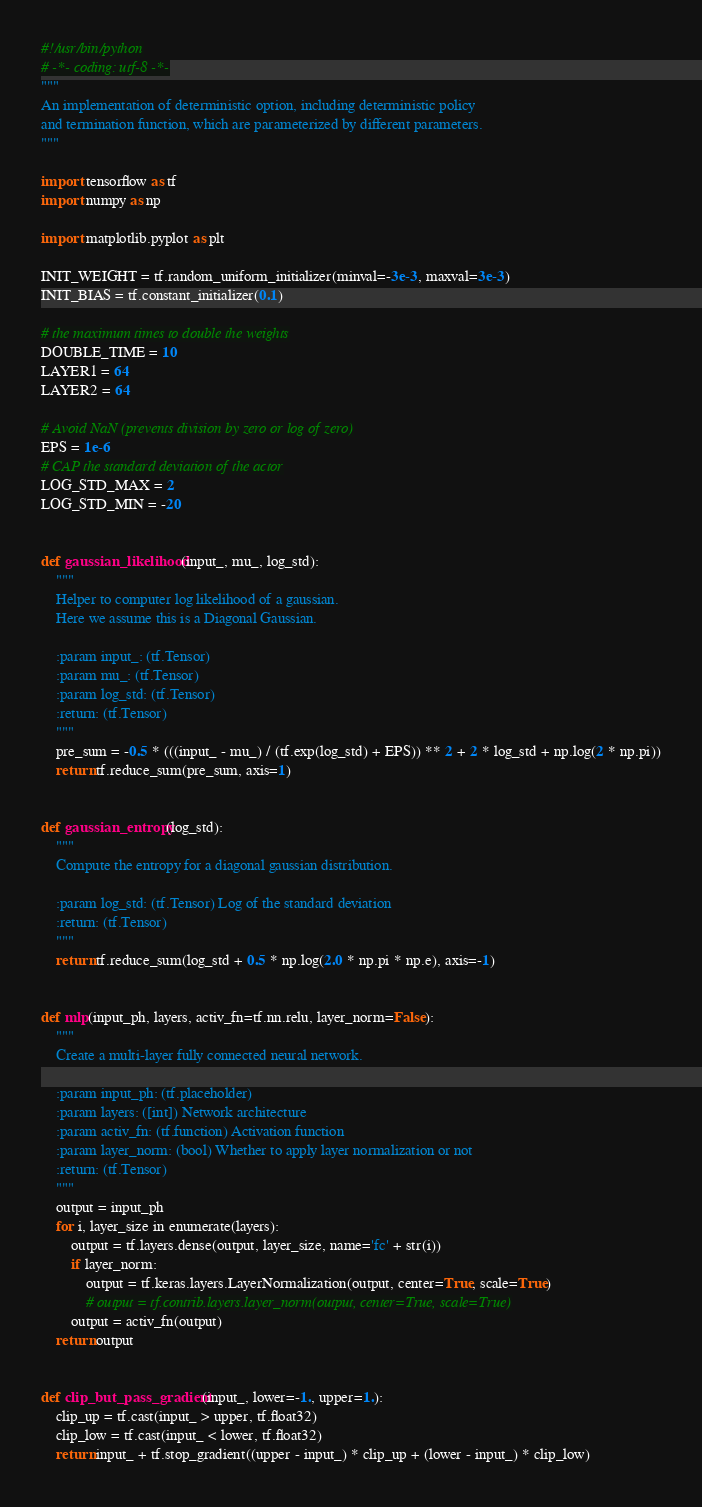<code> <loc_0><loc_0><loc_500><loc_500><_Python_>#!/usr/bin/python
# -*- coding: utf-8 -*-
"""
An implementation of deterministic option, including deterministic policy
and termination function, which are parameterized by different parameters.
"""

import tensorflow as tf
import numpy as np

import matplotlib.pyplot as plt

INIT_WEIGHT = tf.random_uniform_initializer(minval=-3e-3, maxval=3e-3)
INIT_BIAS = tf.constant_initializer(0.1)

# the maximum times to double the weights
DOUBLE_TIME = 10
LAYER1 = 64
LAYER2 = 64

# Avoid NaN (prevents division by zero or log of zero)
EPS = 1e-6
# CAP the standard deviation of the actor
LOG_STD_MAX = 2
LOG_STD_MIN = -20


def gaussian_likelihood(input_, mu_, log_std):
    """
    Helper to computer log likelihood of a gaussian.
    Here we assume this is a Diagonal Gaussian.

    :param input_: (tf.Tensor)
    :param mu_: (tf.Tensor)
    :param log_std: (tf.Tensor)
    :return: (tf.Tensor)
    """
    pre_sum = -0.5 * (((input_ - mu_) / (tf.exp(log_std) + EPS)) ** 2 + 2 * log_std + np.log(2 * np.pi))
    return tf.reduce_sum(pre_sum, axis=1)


def gaussian_entropy(log_std):
    """
    Compute the entropy for a diagonal gaussian distribution.

    :param log_std: (tf.Tensor) Log of the standard deviation
    :return: (tf.Tensor)
    """
    return tf.reduce_sum(log_std + 0.5 * np.log(2.0 * np.pi * np.e), axis=-1)


def mlp(input_ph, layers, activ_fn=tf.nn.relu, layer_norm=False):
    """
    Create a multi-layer fully connected neural network.

    :param input_ph: (tf.placeholder)
    :param layers: ([int]) Network architecture
    :param activ_fn: (tf.function) Activation function
    :param layer_norm: (bool) Whether to apply layer normalization or not
    :return: (tf.Tensor)
    """
    output = input_ph
    for i, layer_size in enumerate(layers):
        output = tf.layers.dense(output, layer_size, name='fc' + str(i))
        if layer_norm:
            output = tf.keras.layers.LayerNormalization(output, center=True, scale=True)
            # output = tf.contrib.layers.layer_norm(output, center=True, scale=True)
        output = activ_fn(output)
    return output


def clip_but_pass_gradient(input_, lower=-1., upper=1.):
    clip_up = tf.cast(input_ > upper, tf.float32)
    clip_low = tf.cast(input_ < lower, tf.float32)
    return input_ + tf.stop_gradient((upper - input_) * clip_up + (lower - input_) * clip_low)

</code> 